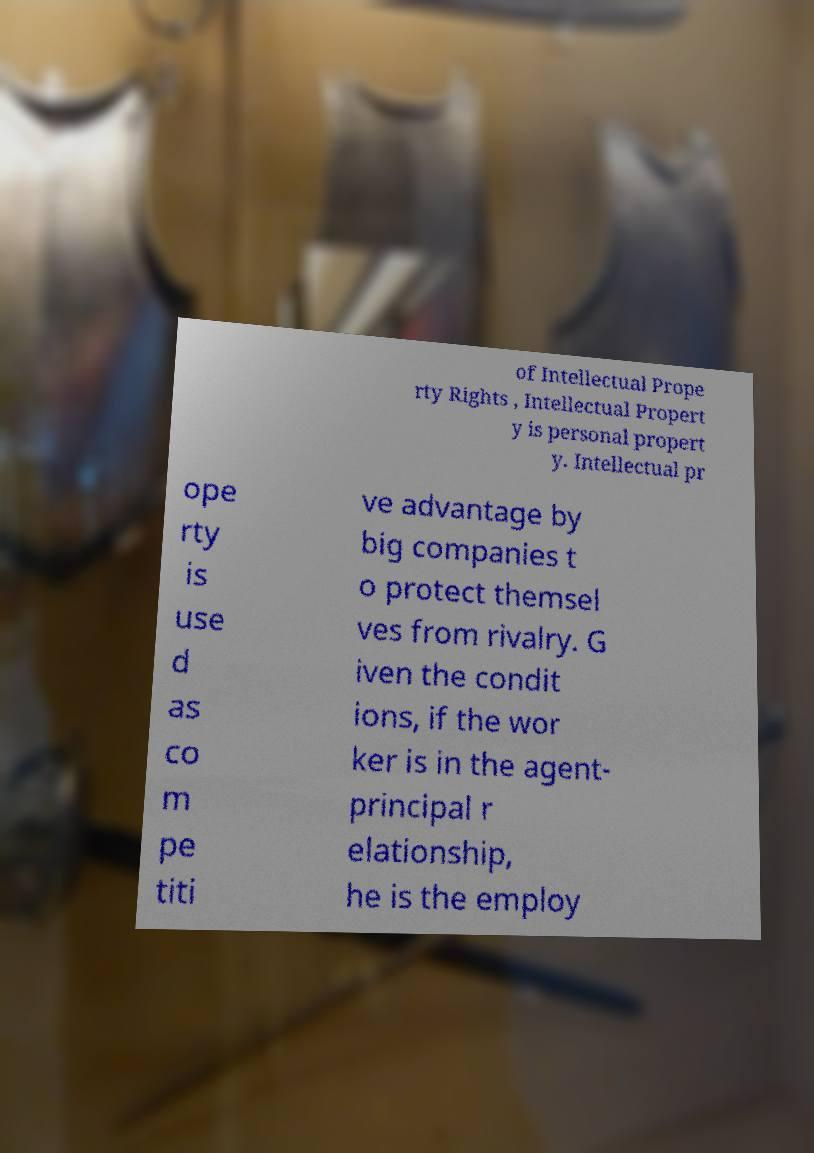There's text embedded in this image that I need extracted. Can you transcribe it verbatim? of Intellectual Prope rty Rights , Intellectual Propert y is personal propert y. Intellectual pr ope rty is use d as co m pe titi ve advantage by big companies t o protect themsel ves from rivalry. G iven the condit ions, if the wor ker is in the agent- principal r elationship, he is the employ 